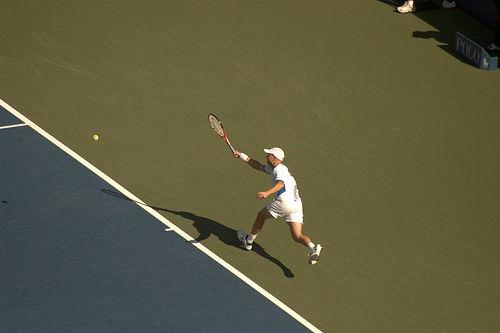Is the man's shadow behind him?
Keep it brief. No. What is the man in the picture about to do?
Give a very brief answer. Hit ball. What is the man holding?
Write a very short answer. Tennis racket. Is the man sleeping?
Quick response, please. No. 